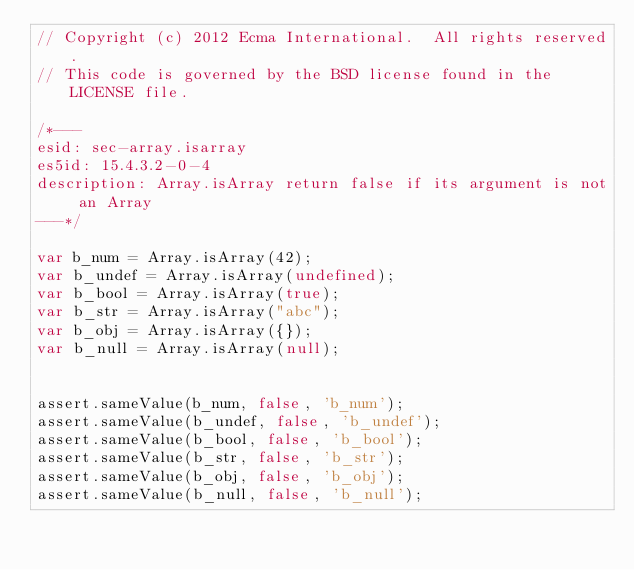Convert code to text. <code><loc_0><loc_0><loc_500><loc_500><_JavaScript_>// Copyright (c) 2012 Ecma International.  All rights reserved.
// This code is governed by the BSD license found in the LICENSE file.

/*---
esid: sec-array.isarray
es5id: 15.4.3.2-0-4
description: Array.isArray return false if its argument is not an Array
---*/

var b_num = Array.isArray(42);
var b_undef = Array.isArray(undefined);
var b_bool = Array.isArray(true);
var b_str = Array.isArray("abc");
var b_obj = Array.isArray({});
var b_null = Array.isArray(null);


assert.sameValue(b_num, false, 'b_num');
assert.sameValue(b_undef, false, 'b_undef');
assert.sameValue(b_bool, false, 'b_bool');
assert.sameValue(b_str, false, 'b_str');
assert.sameValue(b_obj, false, 'b_obj');
assert.sameValue(b_null, false, 'b_null');
</code> 